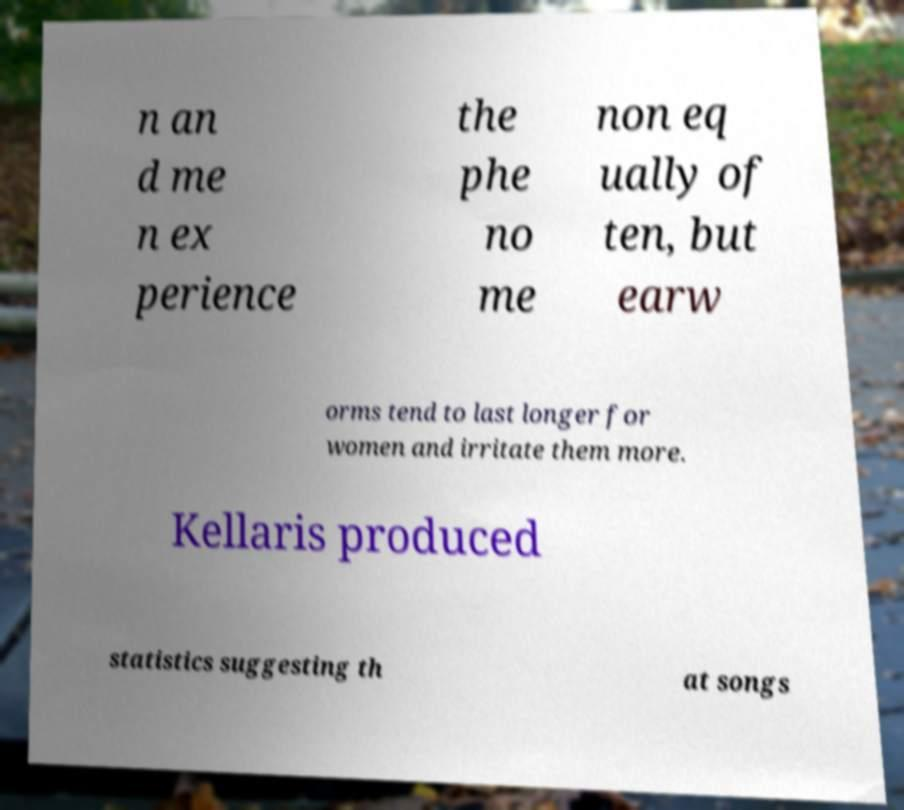Can you accurately transcribe the text from the provided image for me? n an d me n ex perience the phe no me non eq ually of ten, but earw orms tend to last longer for women and irritate them more. Kellaris produced statistics suggesting th at songs 